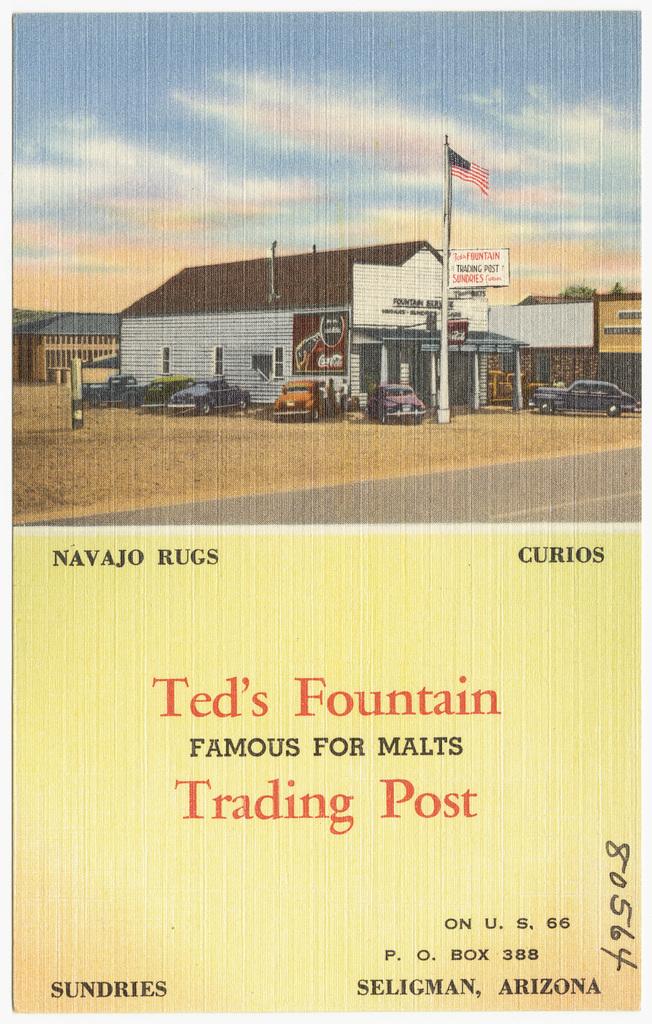Where is the trading post located?
Your answer should be compact. Seligman, arizona. What type of post is mentioned on the post card?
Your answer should be compact. Trading. 